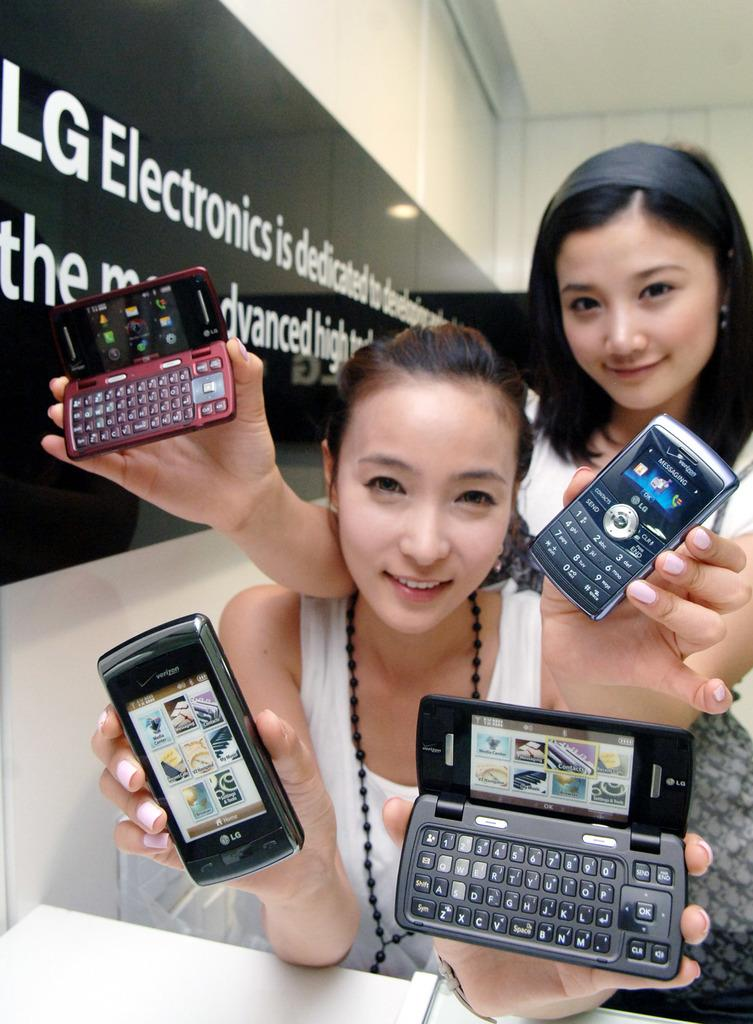<image>
Summarize the visual content of the image. 2 models holding 4 different lg phones and a lg banner/sign in the background 